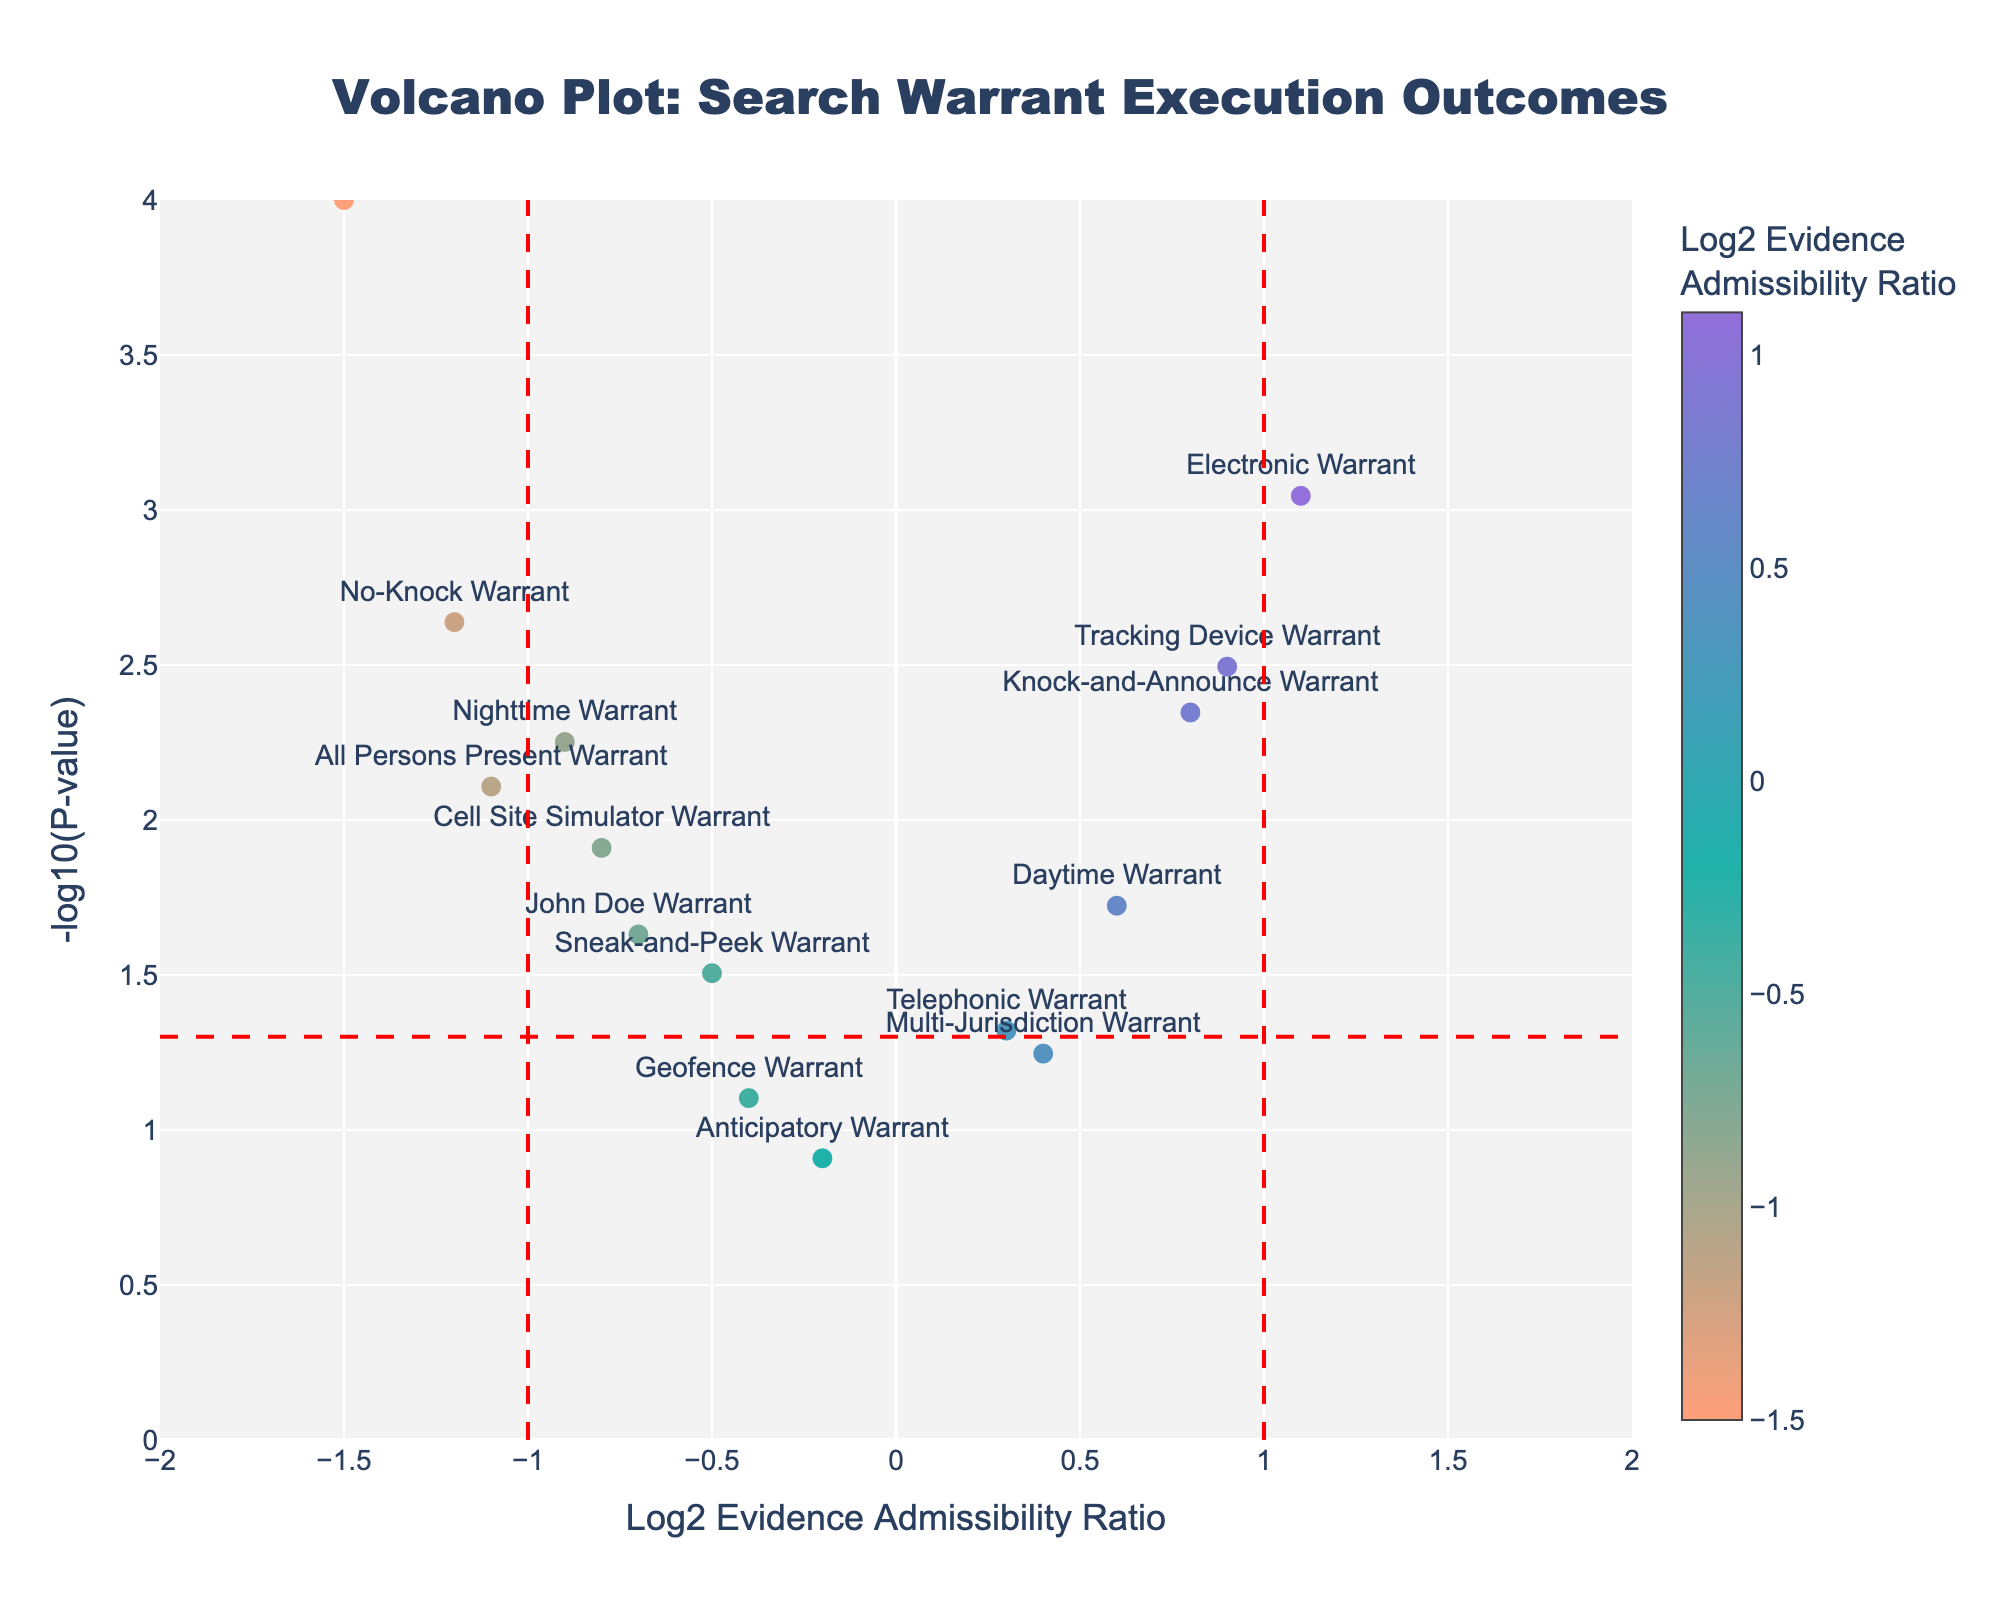What is the title of the figure? The title is usually displayed prominently at the top of the figure, making it easy to identify. In this case, the title specifies the purpose and context of the figure.
Answer: Volcano Plot: Search Warrant Execution Outcomes How many types of search warrants are shown in the plot? Each type of search warrant is represented by a data point on the plot. Counting these data points gives the number of different search warrant types.
Answer: 15 Which search warrant type has the highest Significance value? The y-axis represents the Significance value, and the highest point along this axis indicates the search warrant with the highest Significance.
Answer: Out-of-Jurisdiction Warrant Which warrant type has the lowest Log2 Evidence Admissibility Ratio? The x-axis represents the Log2 Evidence Admissibility Ratio, with the lowest value positioned furthest to the left. Identifying this point reveals the corresponding warrant type.
Answer: Out-of-Jurisdiction Warrant What is the main observation from search warrants with a Log2 Evidence Admissibility Ratio greater than 1? Observations can be made by filtering points to the right of the vertical line at Log2 Evidence Admissibility Ratio = 1, then noting the general characteristics of these points.
Answer: They tend to have higher significance and are associated with increased evidence admissibility What does a point with high Significance and a Log2 Evidence Admissibility Ratio close to zero indicate? High Significance indicates a low p-value, suggesting a statistically significant result. A Log2 Evidence Admissibility Ratio close to zero means the ratio of admissibility between groups is close to 1 or unchanged, despite the significance.
Answer: Likely significant without a substantial change in evidence admissibility Which warrant types fall below the threshold for statistical significance? Points below the horizontal dashed line representing -log10(0.05) indicate warrant types with p-values greater than 0.05, which are not statistically significant.
Answer: Anticipatory Warrant, Multi-Jurisdiction Warrant, Geofence Warrant What is the difference in Log2 Evidence Admissibility Ratio between the Daytime Warrant and the Nighttime Warrant? Compare the x-axis positions of both warrant types and calculate the difference in their Log2 Evidence Admissibility Ratios.
Answer: 1.5 (Daytime: 0.6, Nighttime: -0.9) How many types of warrants show a negative Log2 Evidence Admissibility Ratio? Points with Log2 Evidence Admissibility Ratios to the left of zero (negative values) indicate certain warrant types. Counting these points will give the answer.
Answer: 8 Which warrant type is closest to the vertical line representing a Log2 Evidence Admissibility Ratio of 1 but slightly to its left? Points near the vertical line at Log2 Evidence Admissibility Ratio = 1 are examined to find the one closest but slightly on the left side.
Answer: Knock-and-Announce Warrant 